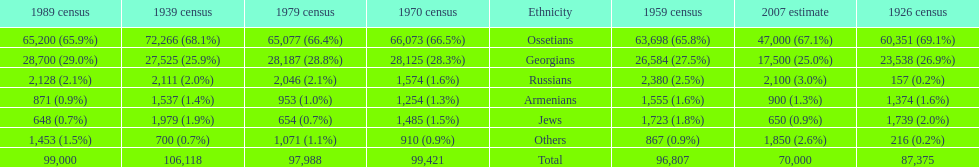Can you give me this table as a dict? {'header': ['1989 census', '1939 census', '1979 census', '1970 census', 'Ethnicity', '1959 census', '2007 estimate', '1926 census'], 'rows': [['65,200 (65.9%)', '72,266 (68.1%)', '65,077 (66.4%)', '66,073 (66.5%)', 'Ossetians', '63,698 (65.8%)', '47,000 (67.1%)', '60,351 (69.1%)'], ['28,700 (29.0%)', '27,525 (25.9%)', '28,187 (28.8%)', '28,125 (28.3%)', 'Georgians', '26,584 (27.5%)', '17,500 (25.0%)', '23,538 (26.9%)'], ['2,128 (2.1%)', '2,111 (2.0%)', '2,046 (2.1%)', '1,574 (1.6%)', 'Russians', '2,380 (2.5%)', '2,100 (3.0%)', '157 (0.2%)'], ['871 (0.9%)', '1,537 (1.4%)', '953 (1.0%)', '1,254 (1.3%)', 'Armenians', '1,555 (1.6%)', '900 (1.3%)', '1,374 (1.6%)'], ['648 (0.7%)', '1,979 (1.9%)', '654 (0.7%)', '1,485 (1.5%)', 'Jews', '1,723 (1.8%)', '650 (0.9%)', '1,739 (2.0%)'], ['1,453 (1.5%)', '700 (0.7%)', '1,071 (1.1%)', '910 (0.9%)', 'Others', '867 (0.9%)', '1,850 (2.6%)', '216 (0.2%)'], ['99,000', '106,118', '97,988', '99,421', 'Total', '96,807', '70,000', '87,375']]} How many russians lived in south ossetia in 1970? 1,574. 